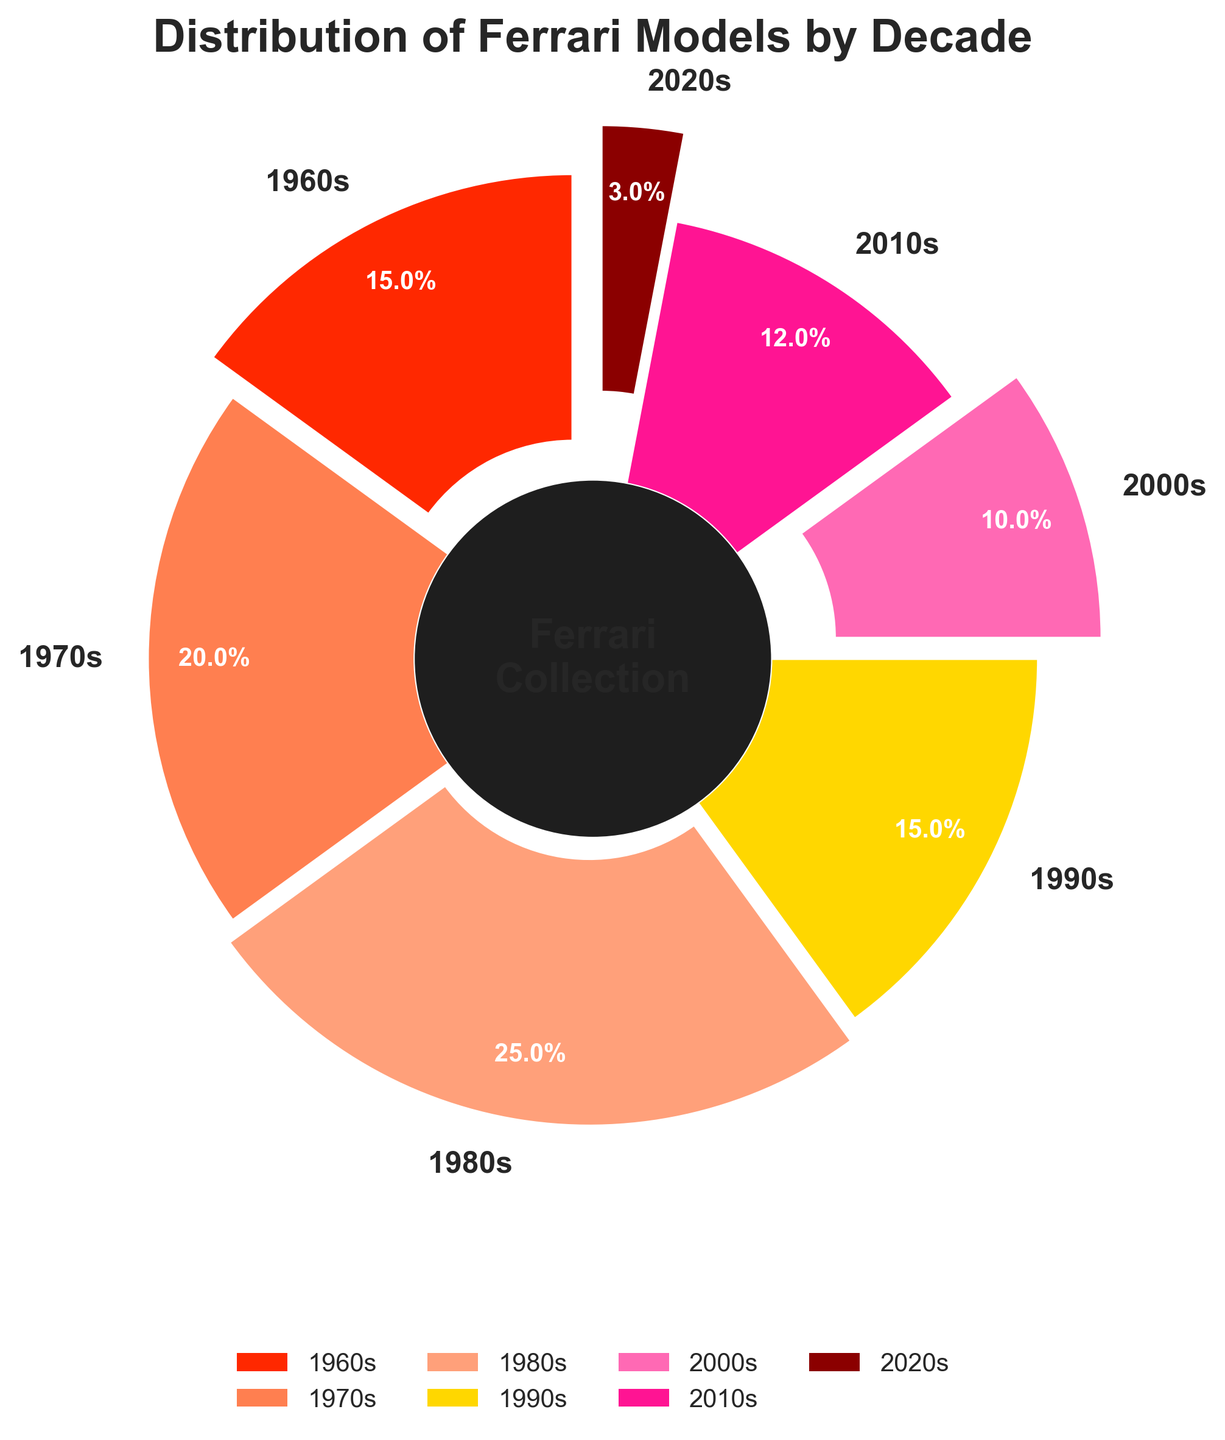What's the percentage of Ferrari models from the 1980s compared to the 2020s? The percentage of Ferrari models from the 1980s is 25%, and from the 2020s is 3%. To compare, subtract the percentage of the 2020s from the 1980s: 25% - 3% = 22%
Answer: 22% Which decade has the smallest share of Ferrari models? By visually inspecting the pie chart, the smallest wedge represents the 2020s, which occupies only 3% of the chart.
Answer: 2020s Do the combined percentages of Ferrari models from the 1960s and the 1990s exceed the percentage from the 1980s? The percentage of Ferrari models from the 1960s is 15%, and from the 1990s is also 15%. When combined: 15% + 15% = 30%. This is greater than the 25% from the 1980s.
Answer: Yes How much more prevalent are Ferrari models from the 1970s compared to the 2010s? The percentage of Ferrari models from the 1970s is 20%, whereas models from the 2010s make up 12%. The difference is calculated as 20% - 12% = 8%.
Answer: 8% What percentage of the collection is made up of Ferrari models from the 2000s? By referring to the pie chart, the percentage of Ferrari models from the 2000s is indicated as 10%.
Answer: 10% If you were to highlight the decade with the highest percentage using the largest wedge, which decade would it be? Visually inspecting the wedges, the 1980s has the largest segment, indicating the highest percentage at 25%.
Answer: 1980s Is the sum of the percentages of Ferrari models from the 1970s and the 2010s greater than the percentage of models from the 1960s and 2000s combined? Sum of the 1970s and 2010s: 20% + 12% = 32%. Sum of the 1960s and 2000s: 15% + 10% = 25%. 32% is greater than 25%.
Answer: Yes What visual element in the chart is used to center the text “Ferrari Collection”? The chart has a center circle element with a darker shade behind the text “Ferrari Collection” to make it prominent and readable.
Answer: Dark center circle Between which two consecutive decades is the difference in the percentage of Ferrari models the highest? By comparing the differences between consecutive decades: 1970s and 1980s (25% - 20% = 5%), and 2010s and 2020s (12% - 3% = 9%). The largest difference is between the 2010s and 2020s, which is 9%.
Answer: 2010s and 2020s 